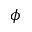<formula> <loc_0><loc_0><loc_500><loc_500>\phi</formula> 